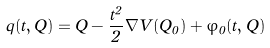<formula> <loc_0><loc_0><loc_500><loc_500>q ( t , Q ) = Q - \frac { t ^ { 2 } } { 2 } \nabla V ( Q _ { 0 } ) + \varphi _ { 0 } ( t , Q )</formula> 